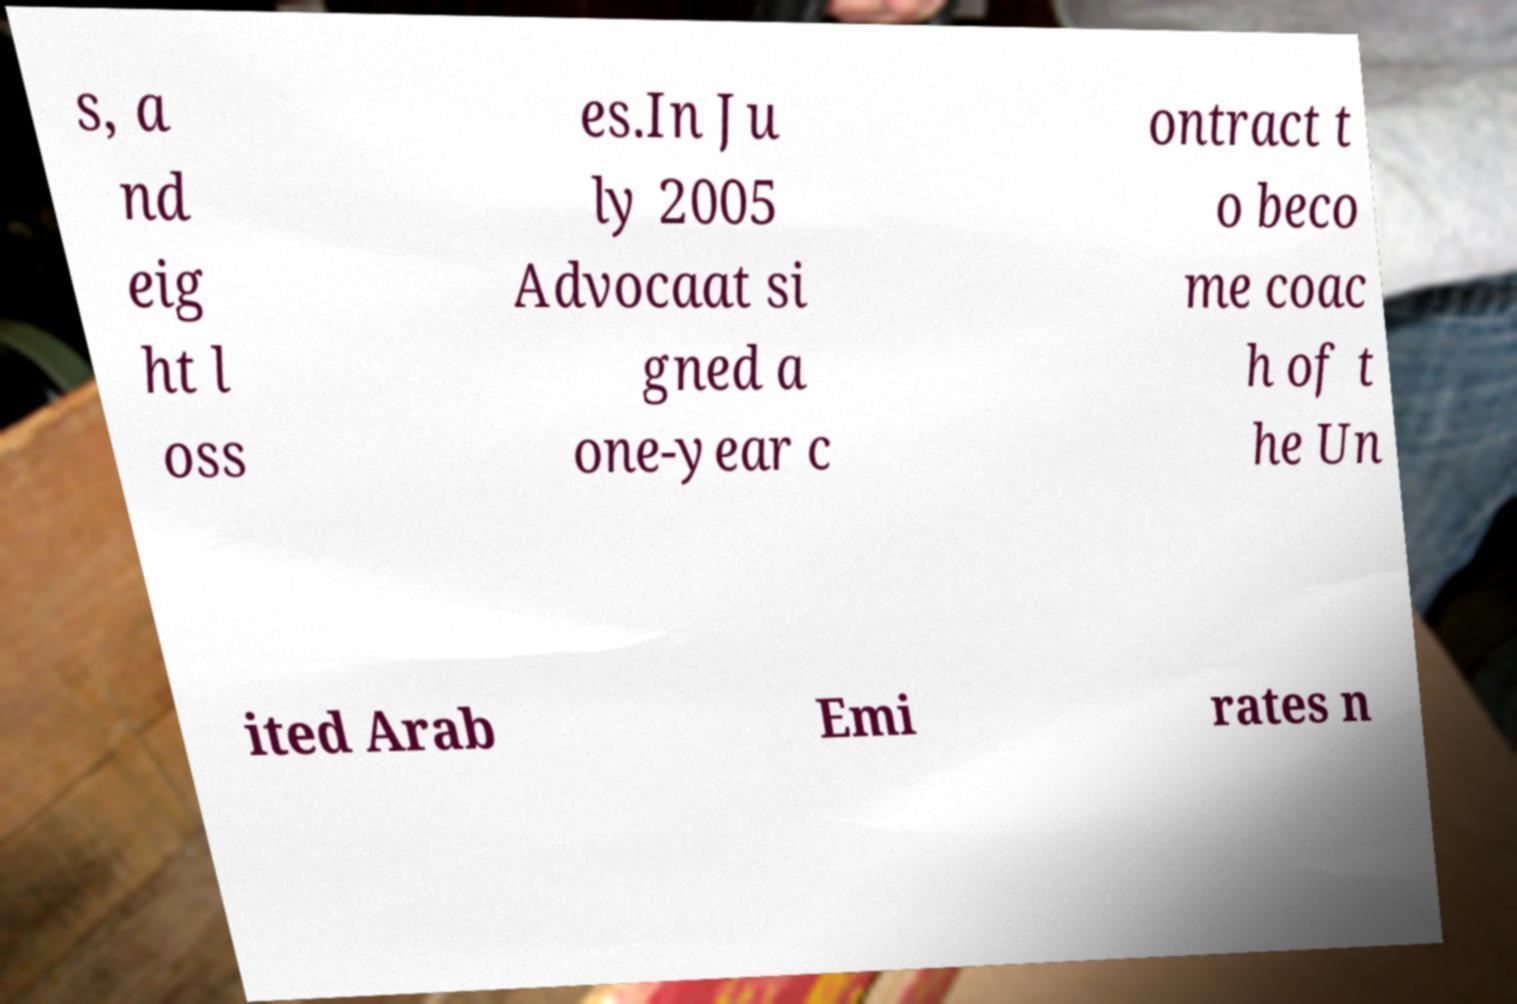Please identify and transcribe the text found in this image. s, a nd eig ht l oss es.In Ju ly 2005 Advocaat si gned a one-year c ontract t o beco me coac h of t he Un ited Arab Emi rates n 